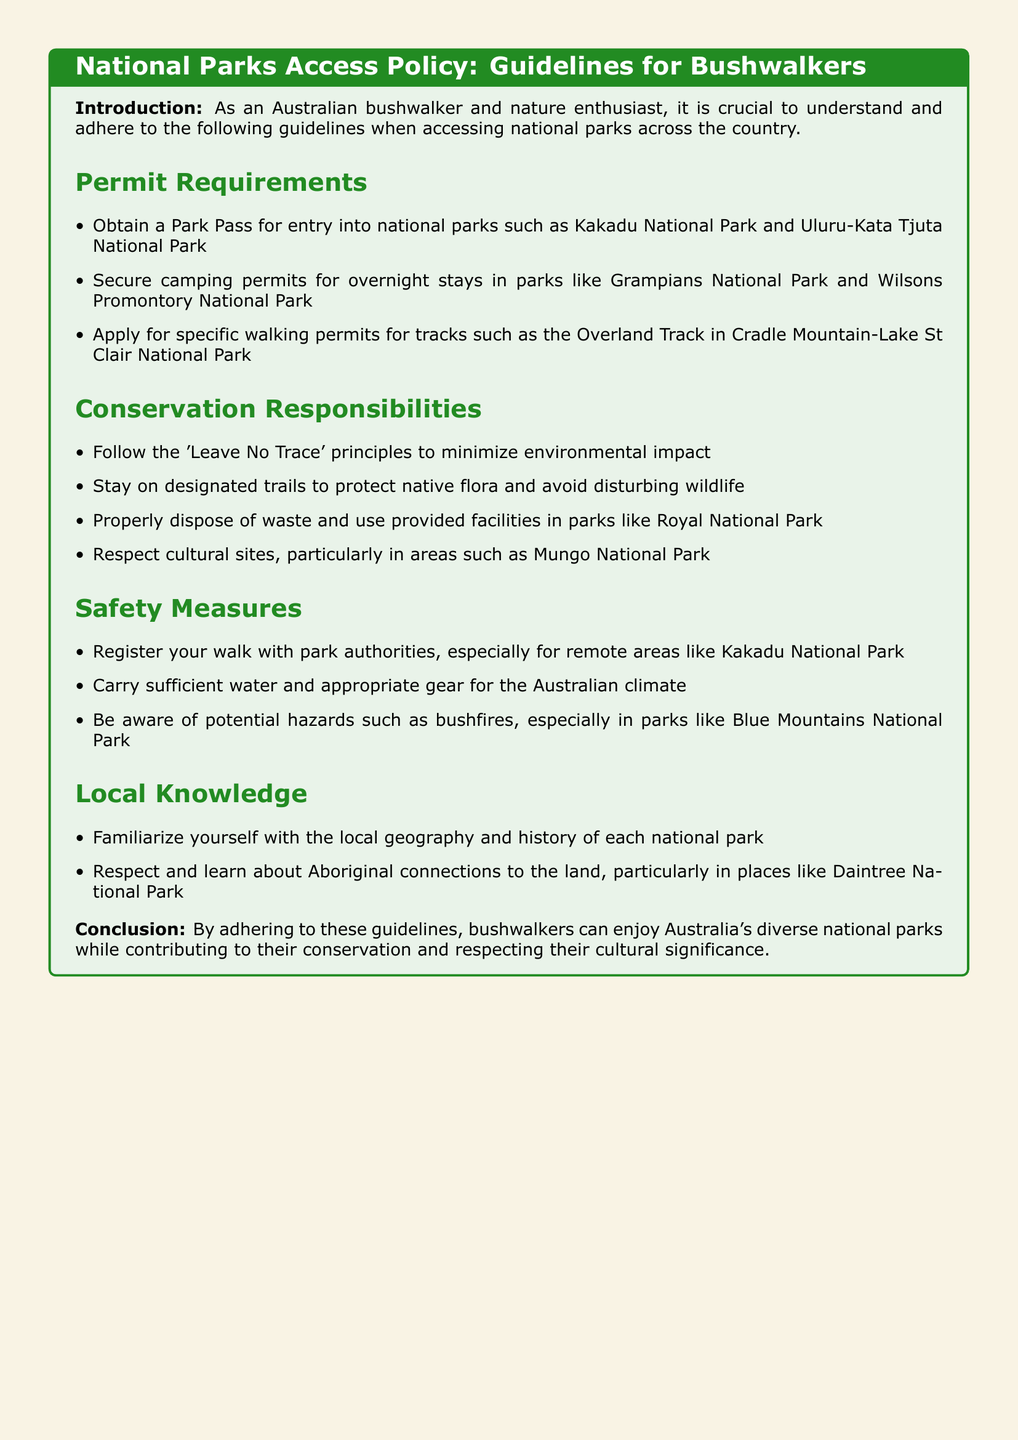What is required for entry into national parks? The document states that a Park Pass is required for entry into national parks like Kakadu National Park and Uluru-Kata Tjuta National Park.
Answer: Park Pass What should bushwalkers follow to minimize environmental impact? The document mentions following the 'Leave No Trace' principles to minimize environmental impact.
Answer: Leave No Trace principles Which national park requires specific walking permits for the Overland Track? The document specifies that Cradle Mountain-Lake St Clair National Park requires specific walking permits for the Overland Track.
Answer: Cradle Mountain-Lake St Clair National Park How should waste be disposed of in Royal National Park? The document indicates that waste should be properly disposed of and provided facilities should be used in parks like Royal National Park.
Answer: Properly dispose of waste What safety measure involves registering walks with park authorities? The document highlights that registering your walk with park authorities is a safety measure, especially for remote areas like Kakadu National Park.
Answer: Register your walk What aspect of local knowledge is emphasized in the guidelines? The document emphasizes familiarizing oneself with the local geography and history of each national park.
Answer: Local geography and history What potential hazard should bushwalkers be aware of in Blue Mountains National Park? The document mentions potential hazards such as bushfires in parks like Blue Mountains National Park.
Answer: Bushfires What cultural sites should bushwalkers respect? The document states that cultural sites, particularly in areas like Mungo National Park, should be respected.
Answer: Cultural sites 